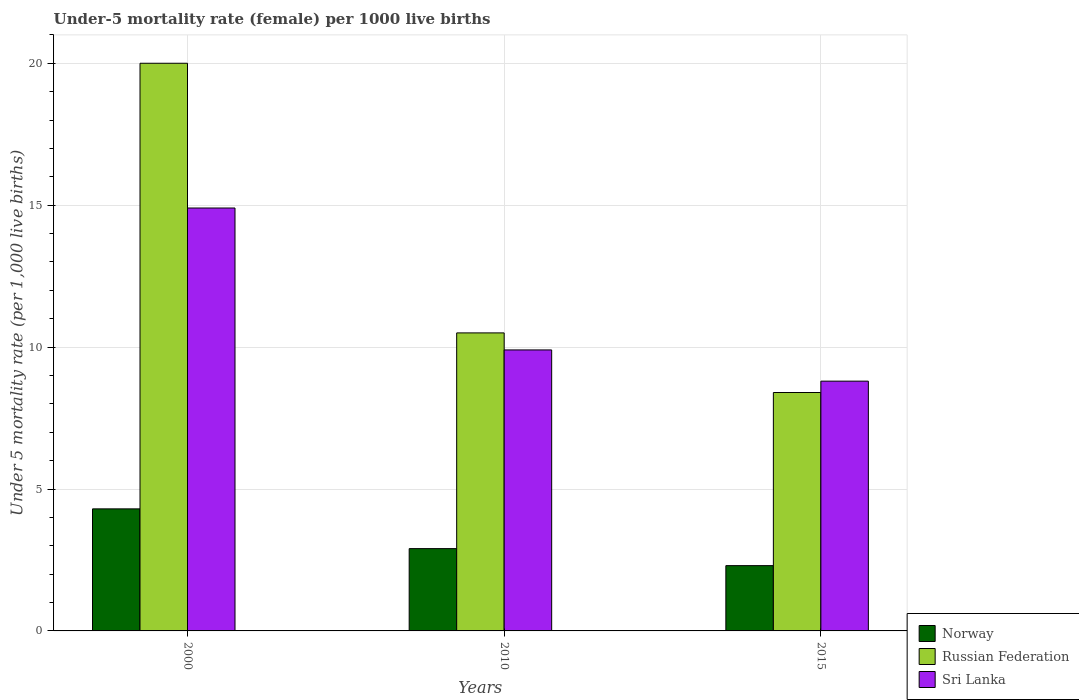How many different coloured bars are there?
Your answer should be compact. 3. How many groups of bars are there?
Give a very brief answer. 3. Are the number of bars per tick equal to the number of legend labels?
Ensure brevity in your answer.  Yes. Are the number of bars on each tick of the X-axis equal?
Offer a terse response. Yes. How many bars are there on the 1st tick from the right?
Provide a short and direct response. 3. What is the under-five mortality rate in Russian Federation in 2000?
Provide a short and direct response. 20. Across all years, what is the maximum under-five mortality rate in Norway?
Provide a succinct answer. 4.3. In which year was the under-five mortality rate in Norway minimum?
Ensure brevity in your answer.  2015. What is the total under-five mortality rate in Norway in the graph?
Provide a succinct answer. 9.5. What is the difference between the under-five mortality rate in Russian Federation in 2010 and that in 2015?
Your answer should be compact. 2.1. What is the average under-five mortality rate in Norway per year?
Offer a very short reply. 3.17. What is the ratio of the under-five mortality rate in Norway in 2010 to that in 2015?
Your response must be concise. 1.26. Is the difference between the under-five mortality rate in Russian Federation in 2000 and 2015 greater than the difference between the under-five mortality rate in Sri Lanka in 2000 and 2015?
Give a very brief answer. Yes. What is the difference between the highest and the second highest under-five mortality rate in Sri Lanka?
Your answer should be very brief. 5. Is the sum of the under-five mortality rate in Norway in 2000 and 2015 greater than the maximum under-five mortality rate in Sri Lanka across all years?
Provide a short and direct response. No. What does the 3rd bar from the left in 2015 represents?
Offer a very short reply. Sri Lanka. What does the 2nd bar from the right in 2000 represents?
Keep it short and to the point. Russian Federation. Is it the case that in every year, the sum of the under-five mortality rate in Russian Federation and under-five mortality rate in Norway is greater than the under-five mortality rate in Sri Lanka?
Provide a succinct answer. Yes. How many bars are there?
Provide a short and direct response. 9. Are the values on the major ticks of Y-axis written in scientific E-notation?
Your answer should be compact. No. Does the graph contain any zero values?
Your answer should be compact. No. Does the graph contain grids?
Provide a short and direct response. Yes. How are the legend labels stacked?
Offer a very short reply. Vertical. What is the title of the graph?
Your response must be concise. Under-5 mortality rate (female) per 1000 live births. What is the label or title of the X-axis?
Provide a short and direct response. Years. What is the label or title of the Y-axis?
Ensure brevity in your answer.  Under 5 mortality rate (per 1,0 live births). What is the Under 5 mortality rate (per 1,000 live births) of Russian Federation in 2000?
Provide a short and direct response. 20. What is the Under 5 mortality rate (per 1,000 live births) of Russian Federation in 2015?
Offer a terse response. 8.4. What is the Under 5 mortality rate (per 1,000 live births) in Sri Lanka in 2015?
Your answer should be compact. 8.8. Across all years, what is the maximum Under 5 mortality rate (per 1,000 live births) in Norway?
Offer a very short reply. 4.3. Across all years, what is the maximum Under 5 mortality rate (per 1,000 live births) in Russian Federation?
Offer a very short reply. 20. Across all years, what is the maximum Under 5 mortality rate (per 1,000 live births) in Sri Lanka?
Your answer should be very brief. 14.9. Across all years, what is the minimum Under 5 mortality rate (per 1,000 live births) in Russian Federation?
Provide a short and direct response. 8.4. Across all years, what is the minimum Under 5 mortality rate (per 1,000 live births) in Sri Lanka?
Your answer should be very brief. 8.8. What is the total Under 5 mortality rate (per 1,000 live births) of Norway in the graph?
Your answer should be very brief. 9.5. What is the total Under 5 mortality rate (per 1,000 live births) of Russian Federation in the graph?
Your answer should be compact. 38.9. What is the total Under 5 mortality rate (per 1,000 live births) in Sri Lanka in the graph?
Keep it short and to the point. 33.6. What is the difference between the Under 5 mortality rate (per 1,000 live births) of Norway in 2000 and that in 2010?
Your response must be concise. 1.4. What is the difference between the Under 5 mortality rate (per 1,000 live births) of Sri Lanka in 2000 and that in 2010?
Ensure brevity in your answer.  5. What is the difference between the Under 5 mortality rate (per 1,000 live births) of Norway in 2000 and that in 2015?
Ensure brevity in your answer.  2. What is the difference between the Under 5 mortality rate (per 1,000 live births) of Russian Federation in 2000 and that in 2015?
Give a very brief answer. 11.6. What is the difference between the Under 5 mortality rate (per 1,000 live births) of Sri Lanka in 2000 and that in 2015?
Offer a terse response. 6.1. What is the difference between the Under 5 mortality rate (per 1,000 live births) in Sri Lanka in 2010 and that in 2015?
Your answer should be compact. 1.1. What is the difference between the Under 5 mortality rate (per 1,000 live births) of Russian Federation in 2000 and the Under 5 mortality rate (per 1,000 live births) of Sri Lanka in 2010?
Provide a short and direct response. 10.1. What is the difference between the Under 5 mortality rate (per 1,000 live births) of Norway in 2000 and the Under 5 mortality rate (per 1,000 live births) of Sri Lanka in 2015?
Provide a short and direct response. -4.5. What is the difference between the Under 5 mortality rate (per 1,000 live births) of Norway in 2010 and the Under 5 mortality rate (per 1,000 live births) of Sri Lanka in 2015?
Offer a terse response. -5.9. What is the average Under 5 mortality rate (per 1,000 live births) in Norway per year?
Offer a very short reply. 3.17. What is the average Under 5 mortality rate (per 1,000 live births) in Russian Federation per year?
Provide a succinct answer. 12.97. In the year 2000, what is the difference between the Under 5 mortality rate (per 1,000 live births) in Norway and Under 5 mortality rate (per 1,000 live births) in Russian Federation?
Your answer should be very brief. -15.7. In the year 2000, what is the difference between the Under 5 mortality rate (per 1,000 live births) in Norway and Under 5 mortality rate (per 1,000 live births) in Sri Lanka?
Provide a short and direct response. -10.6. In the year 2010, what is the difference between the Under 5 mortality rate (per 1,000 live births) in Norway and Under 5 mortality rate (per 1,000 live births) in Sri Lanka?
Provide a short and direct response. -7. In the year 2010, what is the difference between the Under 5 mortality rate (per 1,000 live births) in Russian Federation and Under 5 mortality rate (per 1,000 live births) in Sri Lanka?
Ensure brevity in your answer.  0.6. In the year 2015, what is the difference between the Under 5 mortality rate (per 1,000 live births) of Norway and Under 5 mortality rate (per 1,000 live births) of Sri Lanka?
Provide a short and direct response. -6.5. In the year 2015, what is the difference between the Under 5 mortality rate (per 1,000 live births) in Russian Federation and Under 5 mortality rate (per 1,000 live births) in Sri Lanka?
Your answer should be compact. -0.4. What is the ratio of the Under 5 mortality rate (per 1,000 live births) of Norway in 2000 to that in 2010?
Your response must be concise. 1.48. What is the ratio of the Under 5 mortality rate (per 1,000 live births) in Russian Federation in 2000 to that in 2010?
Your response must be concise. 1.9. What is the ratio of the Under 5 mortality rate (per 1,000 live births) in Sri Lanka in 2000 to that in 2010?
Provide a short and direct response. 1.51. What is the ratio of the Under 5 mortality rate (per 1,000 live births) in Norway in 2000 to that in 2015?
Make the answer very short. 1.87. What is the ratio of the Under 5 mortality rate (per 1,000 live births) of Russian Federation in 2000 to that in 2015?
Give a very brief answer. 2.38. What is the ratio of the Under 5 mortality rate (per 1,000 live births) of Sri Lanka in 2000 to that in 2015?
Provide a short and direct response. 1.69. What is the ratio of the Under 5 mortality rate (per 1,000 live births) of Norway in 2010 to that in 2015?
Your answer should be very brief. 1.26. What is the ratio of the Under 5 mortality rate (per 1,000 live births) of Sri Lanka in 2010 to that in 2015?
Provide a succinct answer. 1.12. What is the difference between the highest and the second highest Under 5 mortality rate (per 1,000 live births) of Russian Federation?
Provide a succinct answer. 9.5. What is the difference between the highest and the lowest Under 5 mortality rate (per 1,000 live births) of Russian Federation?
Offer a very short reply. 11.6. 